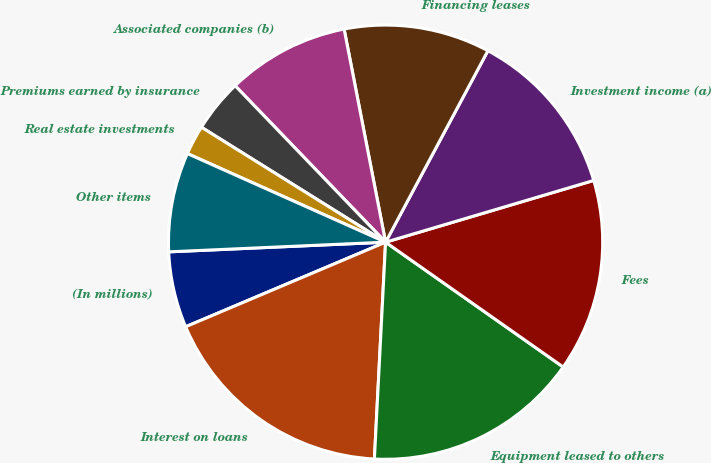Convert chart. <chart><loc_0><loc_0><loc_500><loc_500><pie_chart><fcel>(In millions)<fcel>Interest on loans<fcel>Equipment leased to others<fcel>Fees<fcel>Investment income (a)<fcel>Financing leases<fcel>Associated companies (b)<fcel>Premiums earned by insurance<fcel>Real estate investments<fcel>Other items<nl><fcel>5.66%<fcel>17.81%<fcel>16.07%<fcel>14.34%<fcel>12.6%<fcel>10.87%<fcel>9.13%<fcel>3.93%<fcel>2.19%<fcel>7.4%<nl></chart> 